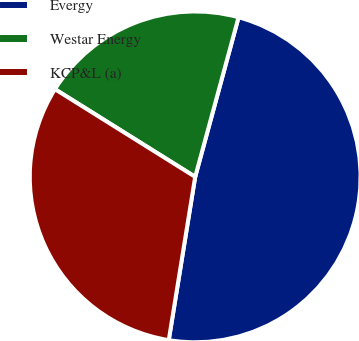Convert chart. <chart><loc_0><loc_0><loc_500><loc_500><pie_chart><fcel>Evergy<fcel>Westar Energy<fcel>KCP&L (a)<nl><fcel>48.33%<fcel>20.33%<fcel>31.34%<nl></chart> 